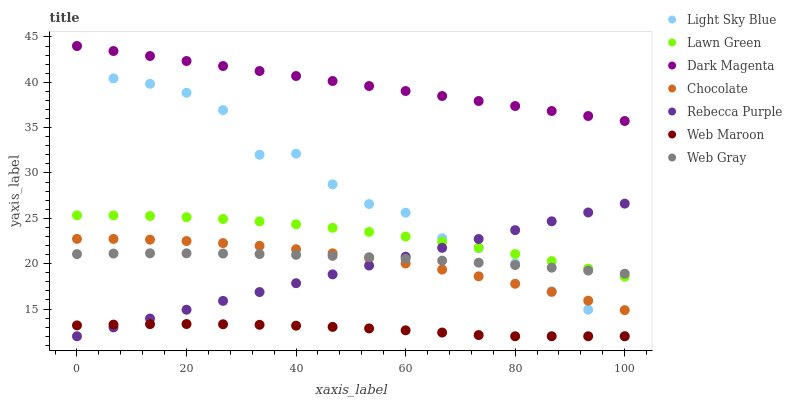Does Web Maroon have the minimum area under the curve?
Answer yes or no. Yes. Does Dark Magenta have the maximum area under the curve?
Answer yes or no. Yes. Does Web Gray have the minimum area under the curve?
Answer yes or no. No. Does Web Gray have the maximum area under the curve?
Answer yes or no. No. Is Rebecca Purple the smoothest?
Answer yes or no. Yes. Is Light Sky Blue the roughest?
Answer yes or no. Yes. Is Web Gray the smoothest?
Answer yes or no. No. Is Web Gray the roughest?
Answer yes or no. No. Does Web Maroon have the lowest value?
Answer yes or no. Yes. Does Web Gray have the lowest value?
Answer yes or no. No. Does Light Sky Blue have the highest value?
Answer yes or no. Yes. Does Web Gray have the highest value?
Answer yes or no. No. Is Web Maroon less than Web Gray?
Answer yes or no. Yes. Is Web Gray greater than Web Maroon?
Answer yes or no. Yes. Does Light Sky Blue intersect Rebecca Purple?
Answer yes or no. Yes. Is Light Sky Blue less than Rebecca Purple?
Answer yes or no. No. Is Light Sky Blue greater than Rebecca Purple?
Answer yes or no. No. Does Web Maroon intersect Web Gray?
Answer yes or no. No. 